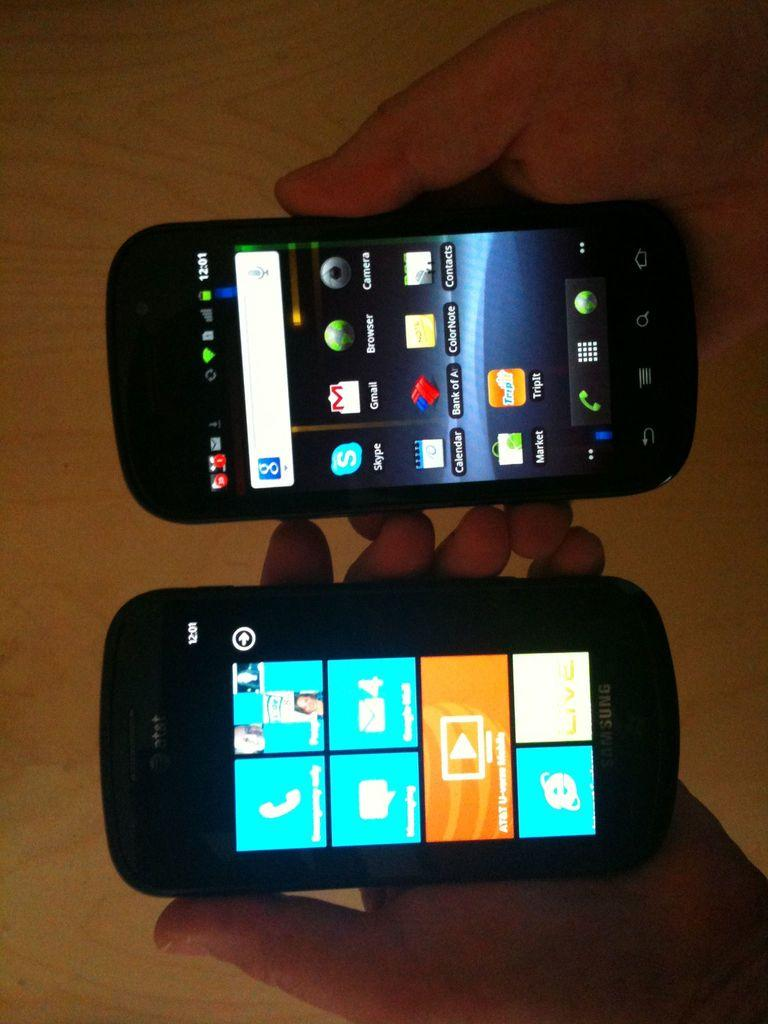<image>
Create a compact narrative representing the image presented. An AT&T phone displays various application tiles on its screen and a second phone displays various icons. 